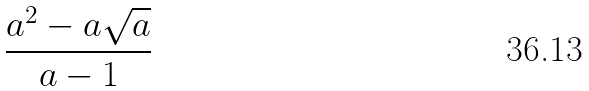<formula> <loc_0><loc_0><loc_500><loc_500>\frac { { a ^ { 2 } } - a \sqrt { a } } { a - 1 }</formula> 